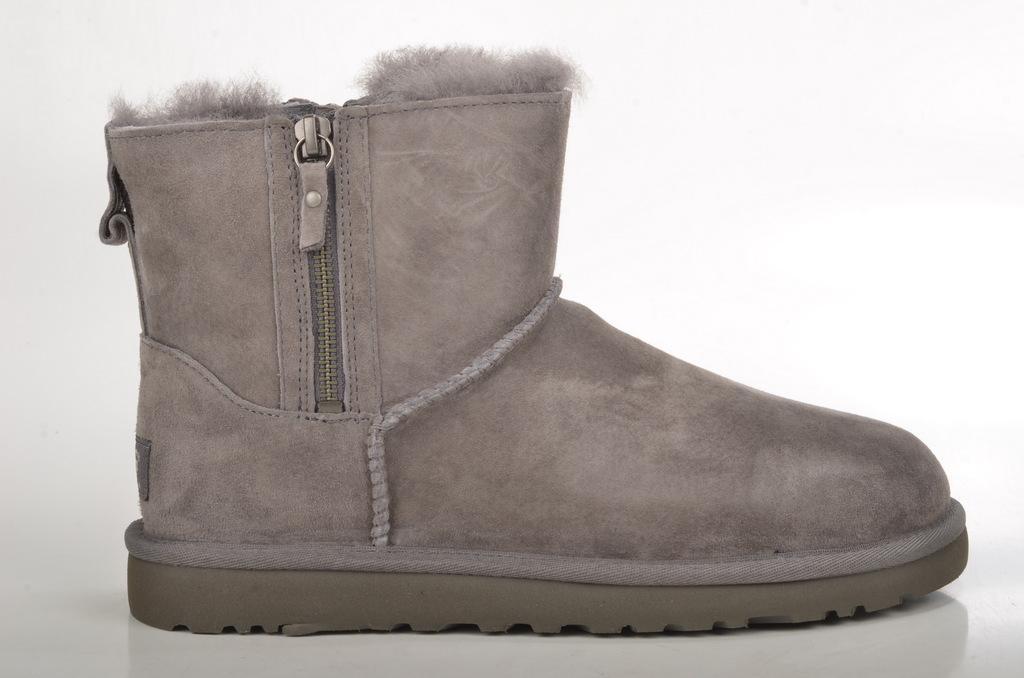Could you give a brief overview of what you see in this image? In this image we can see a mini ankle snow boot placed on the white surface. The background of the image is white in color. 